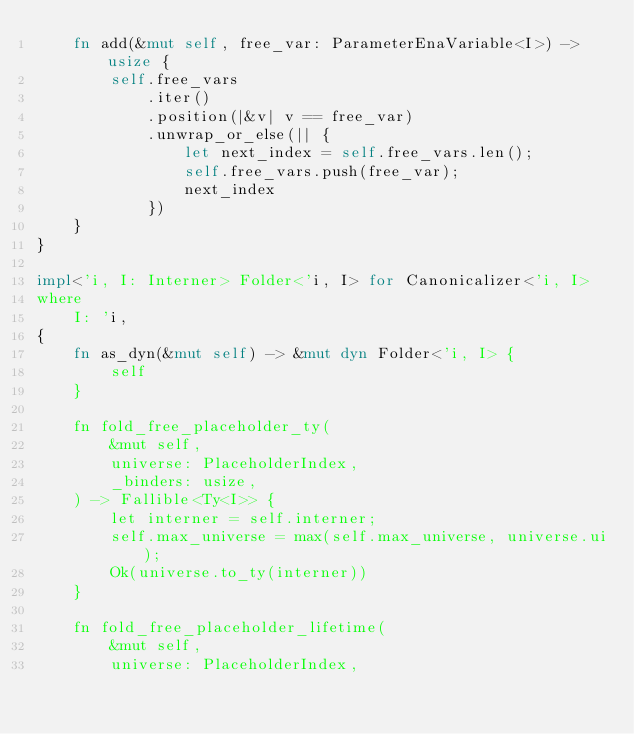<code> <loc_0><loc_0><loc_500><loc_500><_Rust_>    fn add(&mut self, free_var: ParameterEnaVariable<I>) -> usize {
        self.free_vars
            .iter()
            .position(|&v| v == free_var)
            .unwrap_or_else(|| {
                let next_index = self.free_vars.len();
                self.free_vars.push(free_var);
                next_index
            })
    }
}

impl<'i, I: Interner> Folder<'i, I> for Canonicalizer<'i, I>
where
    I: 'i,
{
    fn as_dyn(&mut self) -> &mut dyn Folder<'i, I> {
        self
    }

    fn fold_free_placeholder_ty(
        &mut self,
        universe: PlaceholderIndex,
        _binders: usize,
    ) -> Fallible<Ty<I>> {
        let interner = self.interner;
        self.max_universe = max(self.max_universe, universe.ui);
        Ok(universe.to_ty(interner))
    }

    fn fold_free_placeholder_lifetime(
        &mut self,
        universe: PlaceholderIndex,</code> 